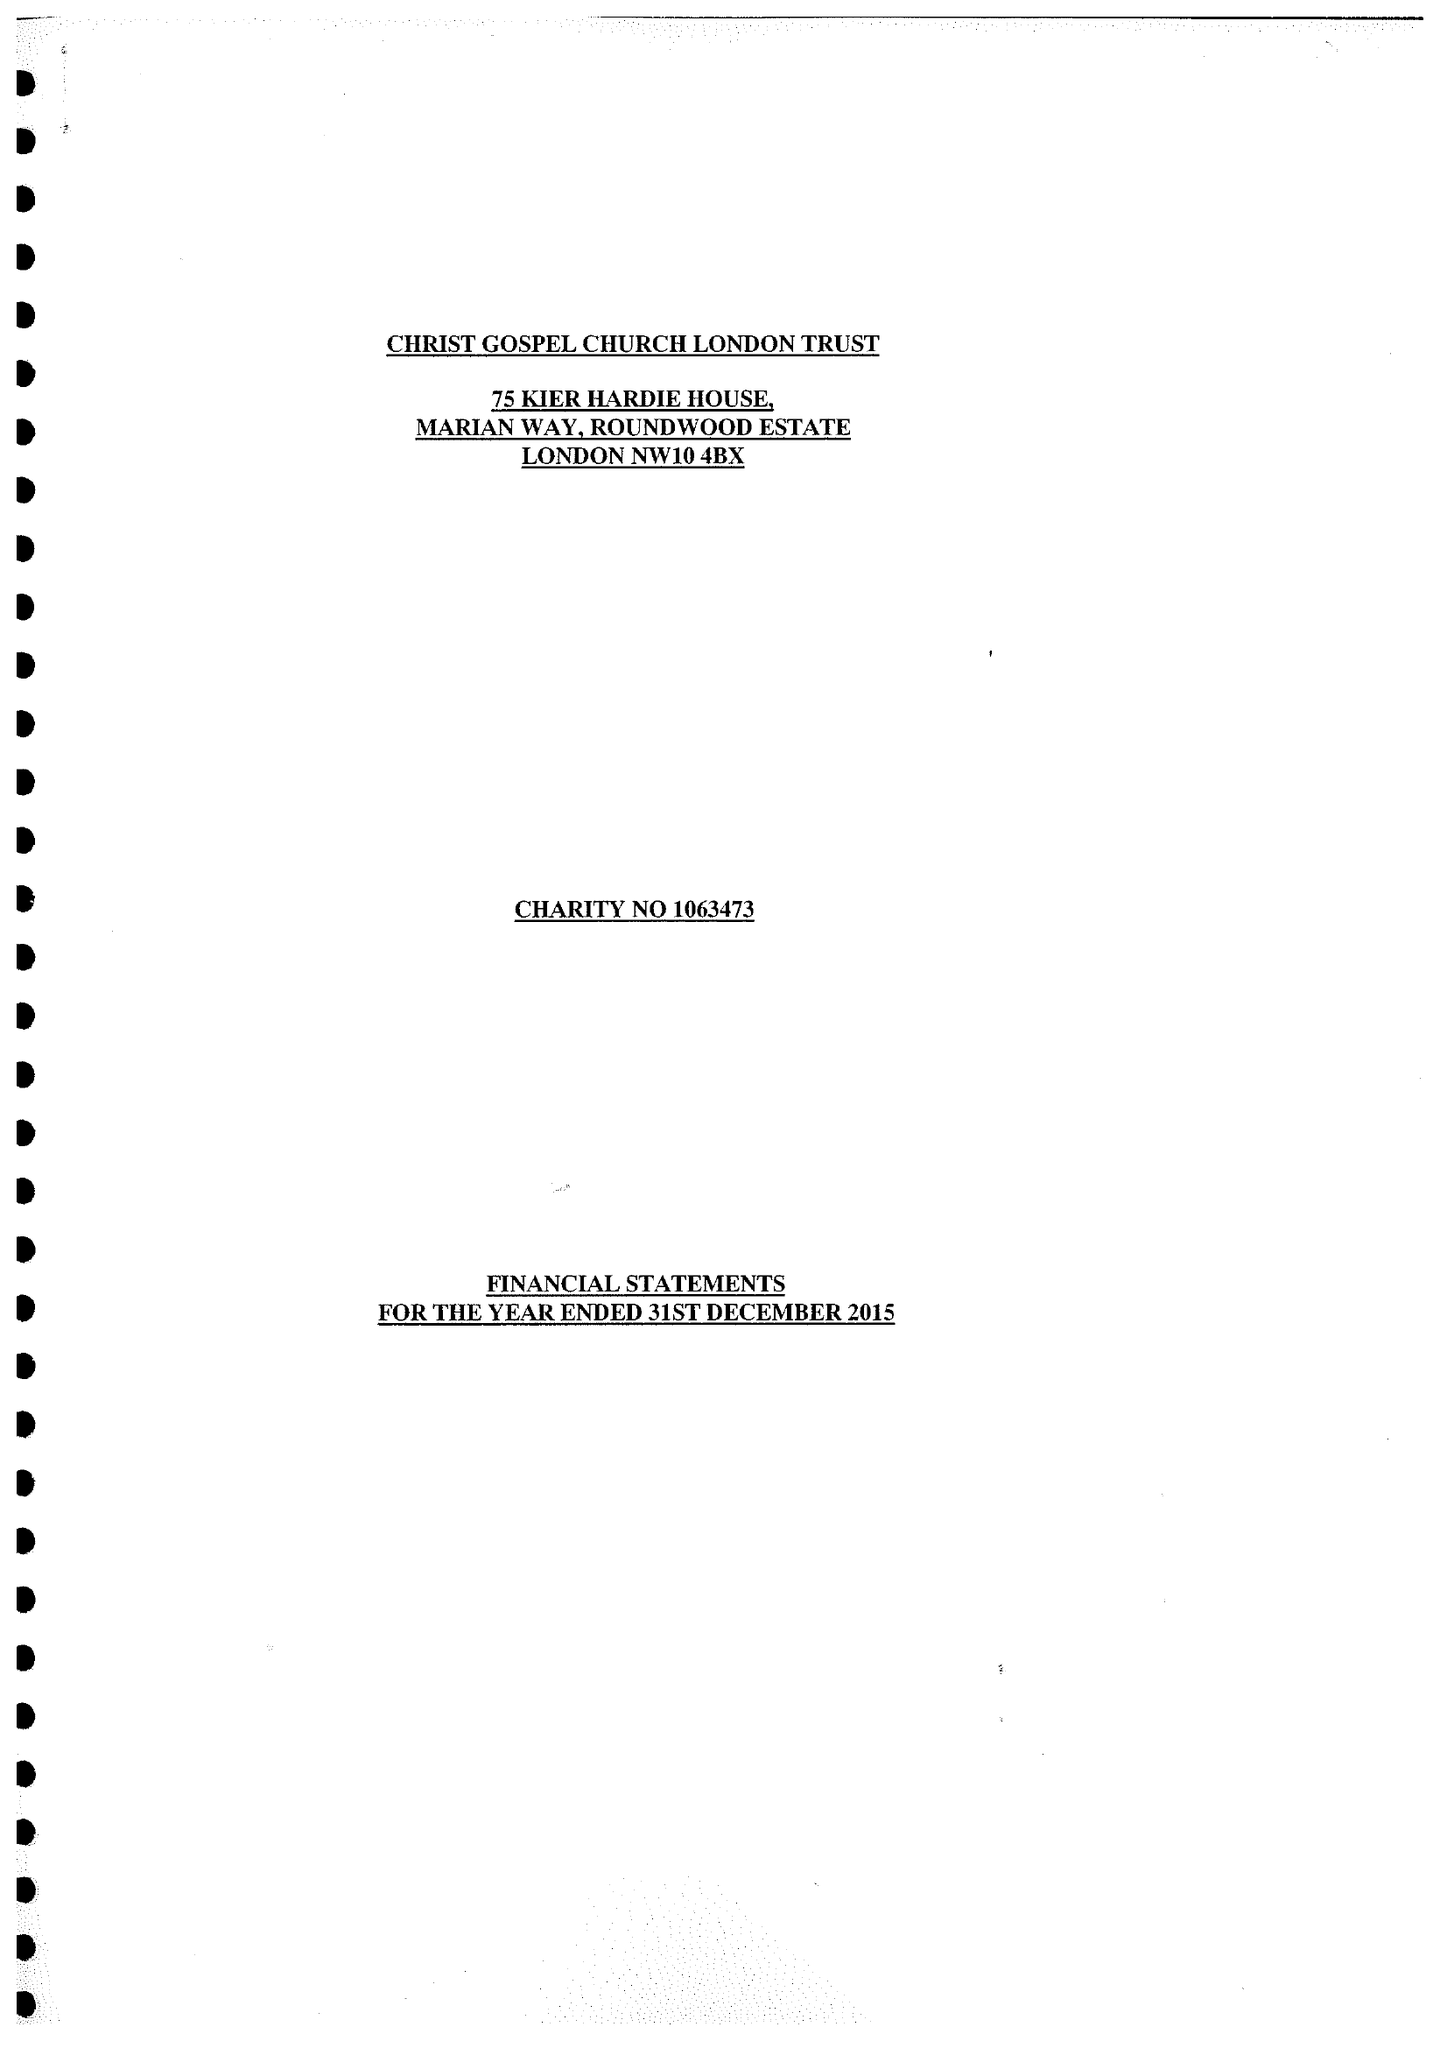What is the value for the income_annually_in_british_pounds?
Answer the question using a single word or phrase. 30442.00 